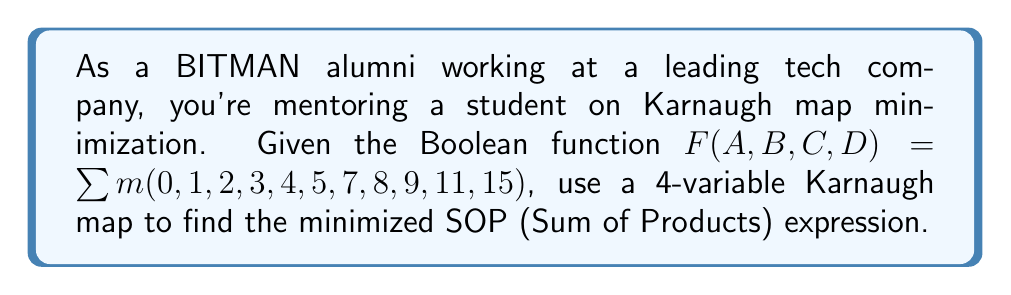Provide a solution to this math problem. 1. Create a 4-variable Karnaugh map:
   [asy]
   unitsize(1cm);
   for(int i=0; i<4; ++i) {
     for(int j=0; j<4; ++j) {
       draw((i,j)--(i+1,j)--(i+1,j+1)--(i,j+1)--cycle);
     }
   }
   label("00", (-0.5,3.5));
   label("01", (-0.5,2.5));
   label("11", (-0.5,1.5));
   label("10", (-0.5,0.5));
   label("00", (0.5,4.5));
   label("01", (1.5,4.5));
   label("11", (2.5,4.5));
   label("10", (3.5,4.5));
   label("AB", (-0.5,4.5));
   label("CD", (4.5,3.5));
   label("1", (0.5,3.5));
   label("1", (1.5,3.5));
   label("1", (2.5,3.5));
   label("1", (3.5,3.5));
   label("1", (0.5,2.5));
   label("1", (1.5,2.5));
   label("1", (3.5,2.5));
   label("1", (3.5,1.5));
   label("1", (0.5,0.5));
   label("1", (1.5,0.5));
   label("1", (3.5,0.5));
   [/asy]

2. Identify the largest possible groups of 1's:
   - Group 1: 8 cells (top row) $\rightarrow \bar{C}$
   - Group 2: 4 cells (left column) $\rightarrow \bar{A}\bar{B}$
   - Group 3: 2 cells (bottom right corner) $\rightarrow A\bar{B}D$

3. Write the minimized SOP expression:
   $F = \bar{C} + \bar{A}\bar{B} + A\bar{B}D$

4. Verify that all minterms are covered:
   - $\bar{C}$ covers minterms 0, 1, 2, 3, 4, 5, 6, 7
   - $\bar{A}\bar{B}$ covers minterms 0, 1, 4, 5
   - $A\bar{B}D$ covers minterms 9, 11

   All given minterms are covered, and no additional minterms are introduced.
Answer: $F = \bar{C} + \bar{A}\bar{B} + A\bar{B}D$ 